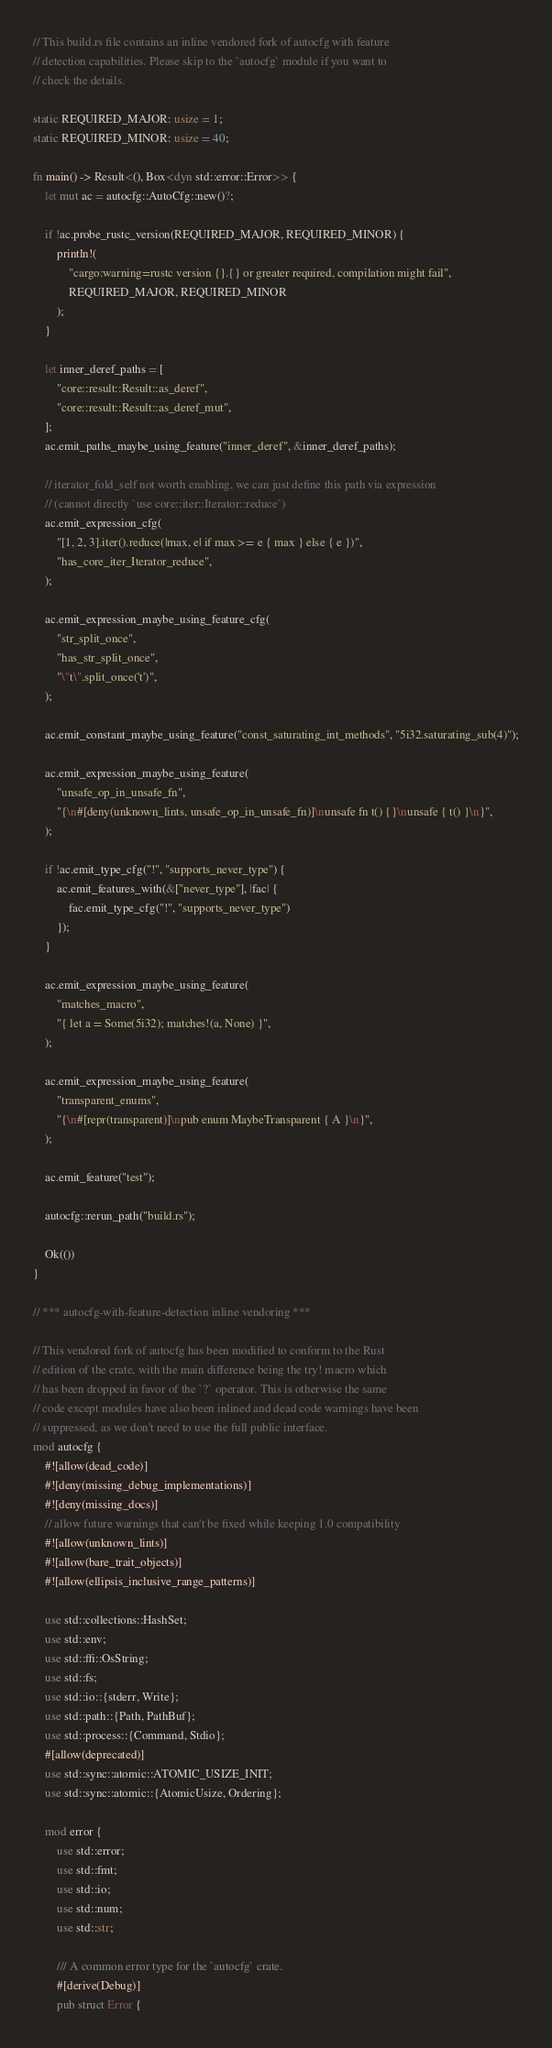Convert code to text. <code><loc_0><loc_0><loc_500><loc_500><_Rust_>// This build.rs file contains an inline vendored fork of autocfg with feature
// detection capabilities. Please skip to the `autocfg` module if you want to
// check the details.

static REQUIRED_MAJOR: usize = 1;
static REQUIRED_MINOR: usize = 40;

fn main() -> Result<(), Box<dyn std::error::Error>> {
    let mut ac = autocfg::AutoCfg::new()?;

    if !ac.probe_rustc_version(REQUIRED_MAJOR, REQUIRED_MINOR) {
        println!(
            "cargo:warning=rustc version {}.{} or greater required, compilation might fail",
            REQUIRED_MAJOR, REQUIRED_MINOR
        );
    }

    let inner_deref_paths = [
        "core::result::Result::as_deref",
        "core::result::Result::as_deref_mut",
    ];
    ac.emit_paths_maybe_using_feature("inner_deref", &inner_deref_paths);

    // iterator_fold_self not worth enabling, we can just define this path via expression
    // (cannot directly `use core::iter::Iterator::reduce`)
    ac.emit_expression_cfg(
        "[1, 2, 3].iter().reduce(|max, e| if max >= e { max } else { e })",
        "has_core_iter_Iterator_reduce",
    );

    ac.emit_expression_maybe_using_feature_cfg(
        "str_split_once",
        "has_str_split_once",
        "\"t\".split_once('t')",
    );

    ac.emit_constant_maybe_using_feature("const_saturating_int_methods", "5i32.saturating_sub(4)");

    ac.emit_expression_maybe_using_feature(
        "unsafe_op_in_unsafe_fn",
        "{\n#[deny(unknown_lints, unsafe_op_in_unsafe_fn)]\nunsafe fn t() {}\nunsafe { t() }\n}",
    );

    if !ac.emit_type_cfg("!", "supports_never_type") {
        ac.emit_features_with(&["never_type"], |fac| {
            fac.emit_type_cfg("!", "supports_never_type")
        });
    }

    ac.emit_expression_maybe_using_feature(
        "matches_macro",
        "{ let a = Some(5i32); matches!(a, None) }",
    );

    ac.emit_expression_maybe_using_feature(
        "transparent_enums",
        "{\n#[repr(transparent)]\npub enum MaybeTransparent { A }\n}",
    );

    ac.emit_feature("test");

    autocfg::rerun_path("build.rs");

    Ok(())
}

// *** autocfg-with-feature-detection inline vendoring ***

// This vendored fork of autocfg has been modified to conform to the Rust
// edition of the crate, with the main difference being the try! macro which
// has been dropped in favor of the `?` operator. This is otherwise the same
// code except modules have also been inlined and dead code warnings have been
// suppressed, as we don't need to use the full public interface.
mod autocfg {
    #![allow(dead_code)]
    #![deny(missing_debug_implementations)]
    #![deny(missing_docs)]
    // allow future warnings that can't be fixed while keeping 1.0 compatibility
    #![allow(unknown_lints)]
    #![allow(bare_trait_objects)]
    #![allow(ellipsis_inclusive_range_patterns)]

    use std::collections::HashSet;
    use std::env;
    use std::ffi::OsString;
    use std::fs;
    use std::io::{stderr, Write};
    use std::path::{Path, PathBuf};
    use std::process::{Command, Stdio};
    #[allow(deprecated)]
    use std::sync::atomic::ATOMIC_USIZE_INIT;
    use std::sync::atomic::{AtomicUsize, Ordering};

    mod error {
        use std::error;
        use std::fmt;
        use std::io;
        use std::num;
        use std::str;

        /// A common error type for the `autocfg` crate.
        #[derive(Debug)]
        pub struct Error {</code> 